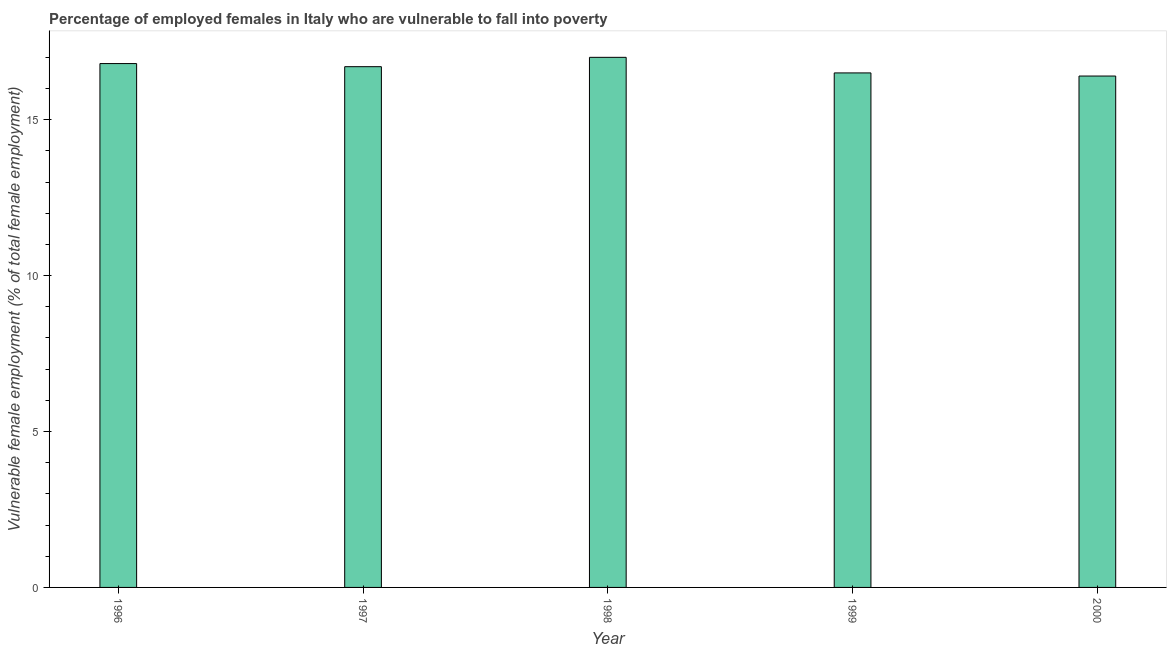What is the title of the graph?
Make the answer very short. Percentage of employed females in Italy who are vulnerable to fall into poverty. What is the label or title of the Y-axis?
Provide a succinct answer. Vulnerable female employment (% of total female employment). Across all years, what is the maximum percentage of employed females who are vulnerable to fall into poverty?
Keep it short and to the point. 17. Across all years, what is the minimum percentage of employed females who are vulnerable to fall into poverty?
Your response must be concise. 16.4. In which year was the percentage of employed females who are vulnerable to fall into poverty maximum?
Your answer should be very brief. 1998. What is the sum of the percentage of employed females who are vulnerable to fall into poverty?
Ensure brevity in your answer.  83.4. What is the difference between the percentage of employed females who are vulnerable to fall into poverty in 1996 and 2000?
Provide a succinct answer. 0.4. What is the average percentage of employed females who are vulnerable to fall into poverty per year?
Keep it short and to the point. 16.68. What is the median percentage of employed females who are vulnerable to fall into poverty?
Your answer should be very brief. 16.7. Is the percentage of employed females who are vulnerable to fall into poverty in 1997 less than that in 1999?
Give a very brief answer. No. Is the difference between the percentage of employed females who are vulnerable to fall into poverty in 1996 and 1998 greater than the difference between any two years?
Provide a short and direct response. No. What is the difference between the highest and the second highest percentage of employed females who are vulnerable to fall into poverty?
Your answer should be very brief. 0.2. Is the sum of the percentage of employed females who are vulnerable to fall into poverty in 1996 and 2000 greater than the maximum percentage of employed females who are vulnerable to fall into poverty across all years?
Ensure brevity in your answer.  Yes. What is the difference between the highest and the lowest percentage of employed females who are vulnerable to fall into poverty?
Your response must be concise. 0.6. In how many years, is the percentage of employed females who are vulnerable to fall into poverty greater than the average percentage of employed females who are vulnerable to fall into poverty taken over all years?
Provide a short and direct response. 3. What is the Vulnerable female employment (% of total female employment) of 1996?
Offer a very short reply. 16.8. What is the Vulnerable female employment (% of total female employment) of 1997?
Your response must be concise. 16.7. What is the Vulnerable female employment (% of total female employment) in 1998?
Offer a very short reply. 17. What is the Vulnerable female employment (% of total female employment) of 2000?
Offer a terse response. 16.4. What is the difference between the Vulnerable female employment (% of total female employment) in 1996 and 1998?
Give a very brief answer. -0.2. What is the difference between the Vulnerable female employment (% of total female employment) in 1996 and 2000?
Offer a terse response. 0.4. What is the difference between the Vulnerable female employment (% of total female employment) in 1997 and 1998?
Ensure brevity in your answer.  -0.3. What is the difference between the Vulnerable female employment (% of total female employment) in 1997 and 1999?
Provide a short and direct response. 0.2. What is the difference between the Vulnerable female employment (% of total female employment) in 1997 and 2000?
Give a very brief answer. 0.3. What is the difference between the Vulnerable female employment (% of total female employment) in 1998 and 2000?
Keep it short and to the point. 0.6. What is the difference between the Vulnerable female employment (% of total female employment) in 1999 and 2000?
Provide a short and direct response. 0.1. What is the ratio of the Vulnerable female employment (% of total female employment) in 1996 to that in 1997?
Provide a short and direct response. 1.01. What is the ratio of the Vulnerable female employment (% of total female employment) in 1996 to that in 1998?
Keep it short and to the point. 0.99. What is the ratio of the Vulnerable female employment (% of total female employment) in 1996 to that in 1999?
Your answer should be compact. 1.02. What is the ratio of the Vulnerable female employment (% of total female employment) in 1996 to that in 2000?
Provide a succinct answer. 1.02. What is the ratio of the Vulnerable female employment (% of total female employment) in 1997 to that in 1999?
Give a very brief answer. 1.01. What is the ratio of the Vulnerable female employment (% of total female employment) in 1998 to that in 1999?
Your response must be concise. 1.03. 